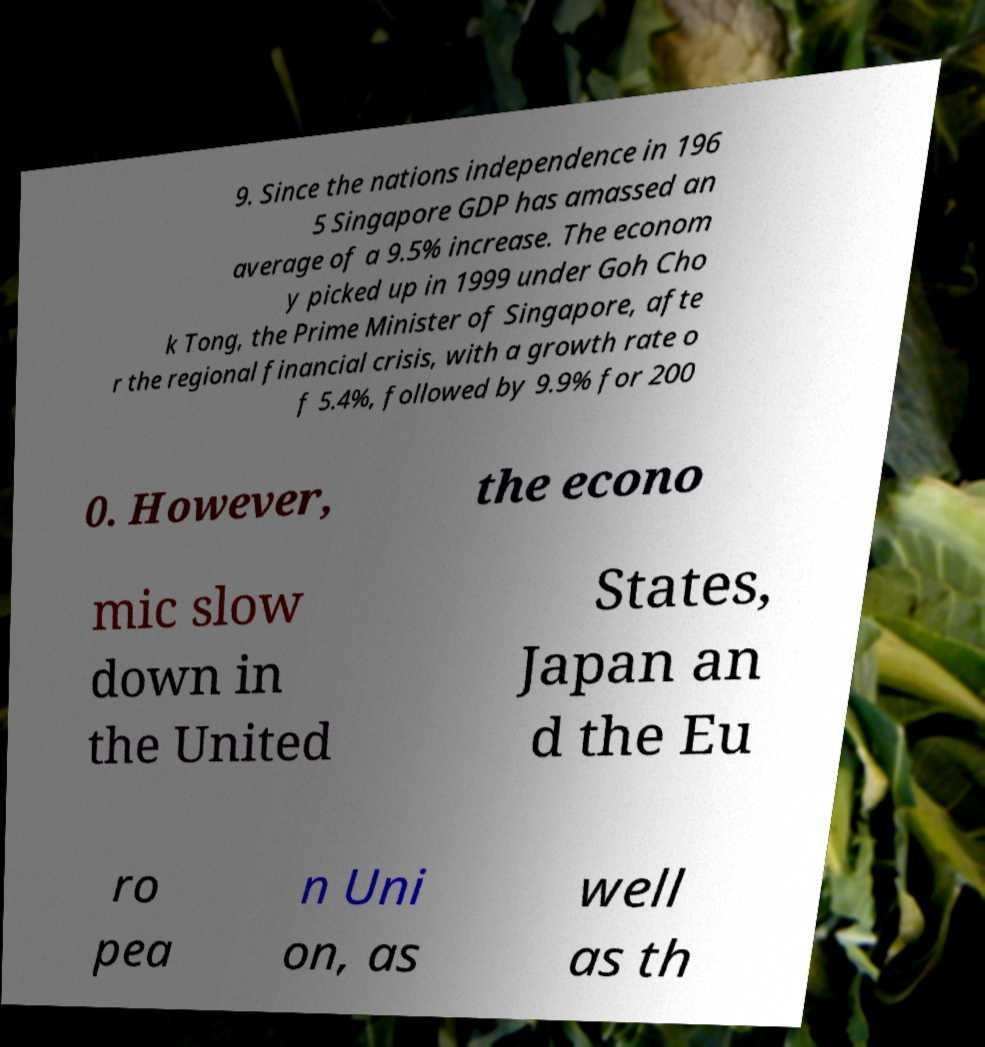Please identify and transcribe the text found in this image. 9. Since the nations independence in 196 5 Singapore GDP has amassed an average of a 9.5% increase. The econom y picked up in 1999 under Goh Cho k Tong, the Prime Minister of Singapore, afte r the regional financial crisis, with a growth rate o f 5.4%, followed by 9.9% for 200 0. However, the econo mic slow down in the United States, Japan an d the Eu ro pea n Uni on, as well as th 